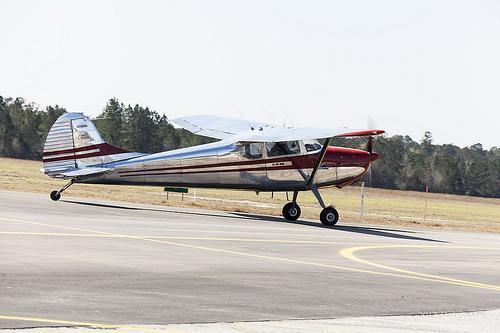How many wheels does the airplane have?
Give a very brief answer. 3. 